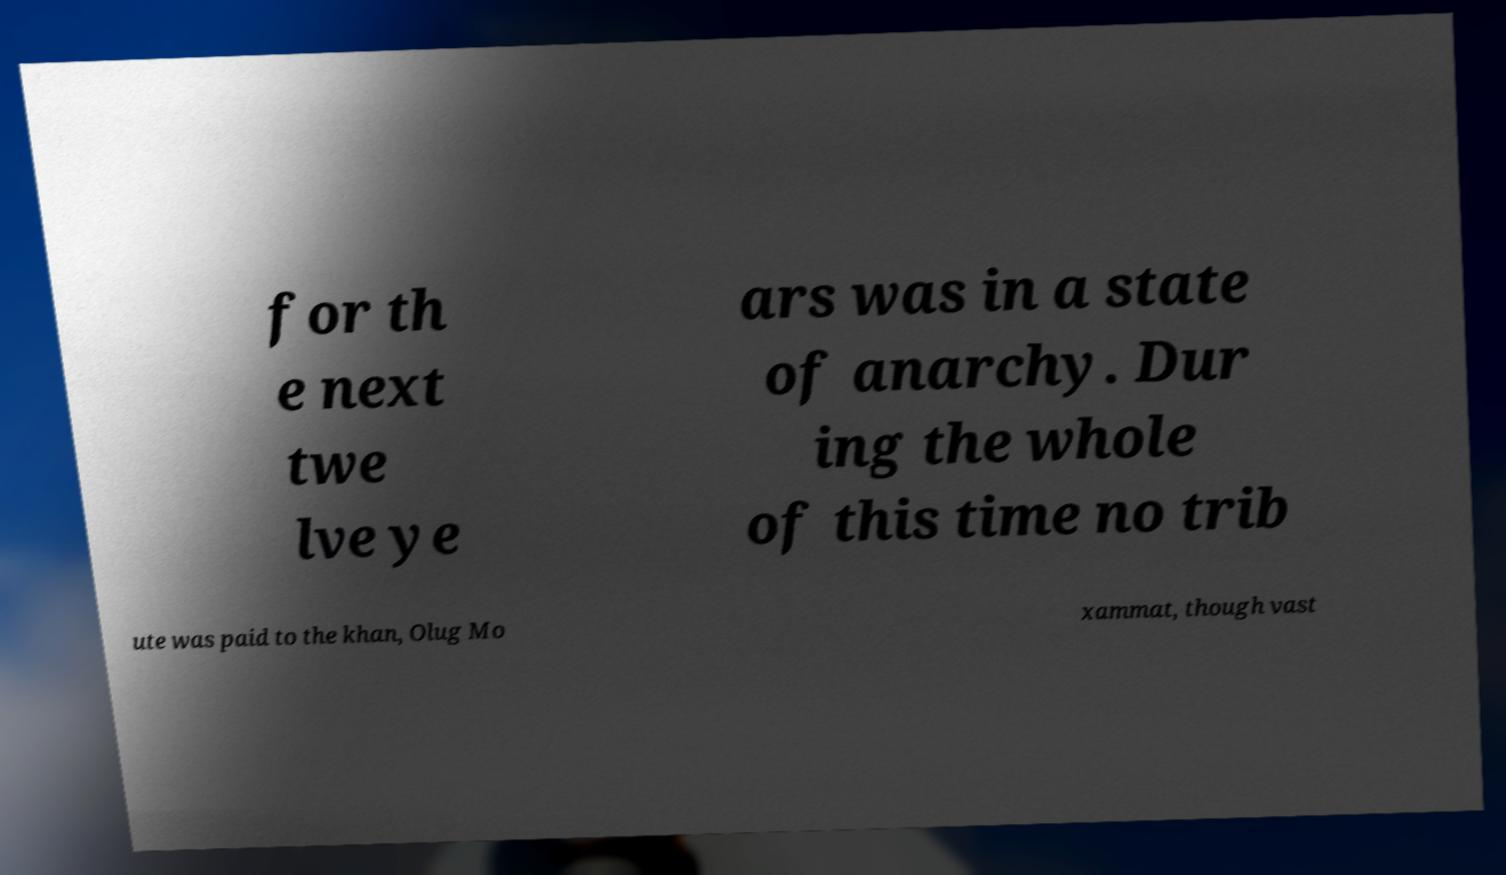Please read and relay the text visible in this image. What does it say? for th e next twe lve ye ars was in a state of anarchy. Dur ing the whole of this time no trib ute was paid to the khan, Olug Mo xammat, though vast 